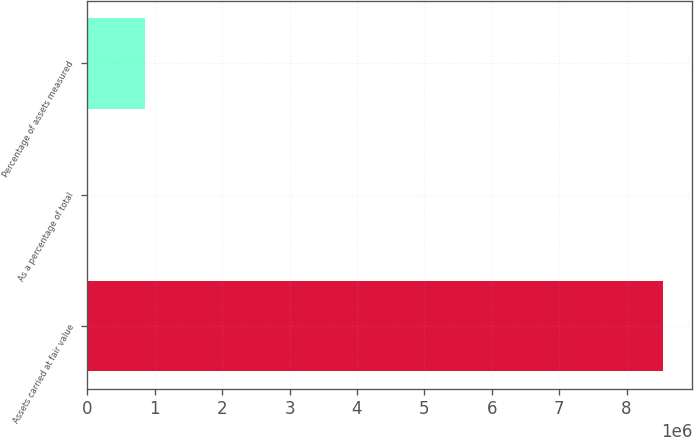Convert chart. <chart><loc_0><loc_0><loc_500><loc_500><bar_chart><fcel>Assets carried at fair value<fcel>As a percentage of total<fcel>Percentage of assets measured<nl><fcel>8.54653e+06<fcel>48.8<fcel>854697<nl></chart> 